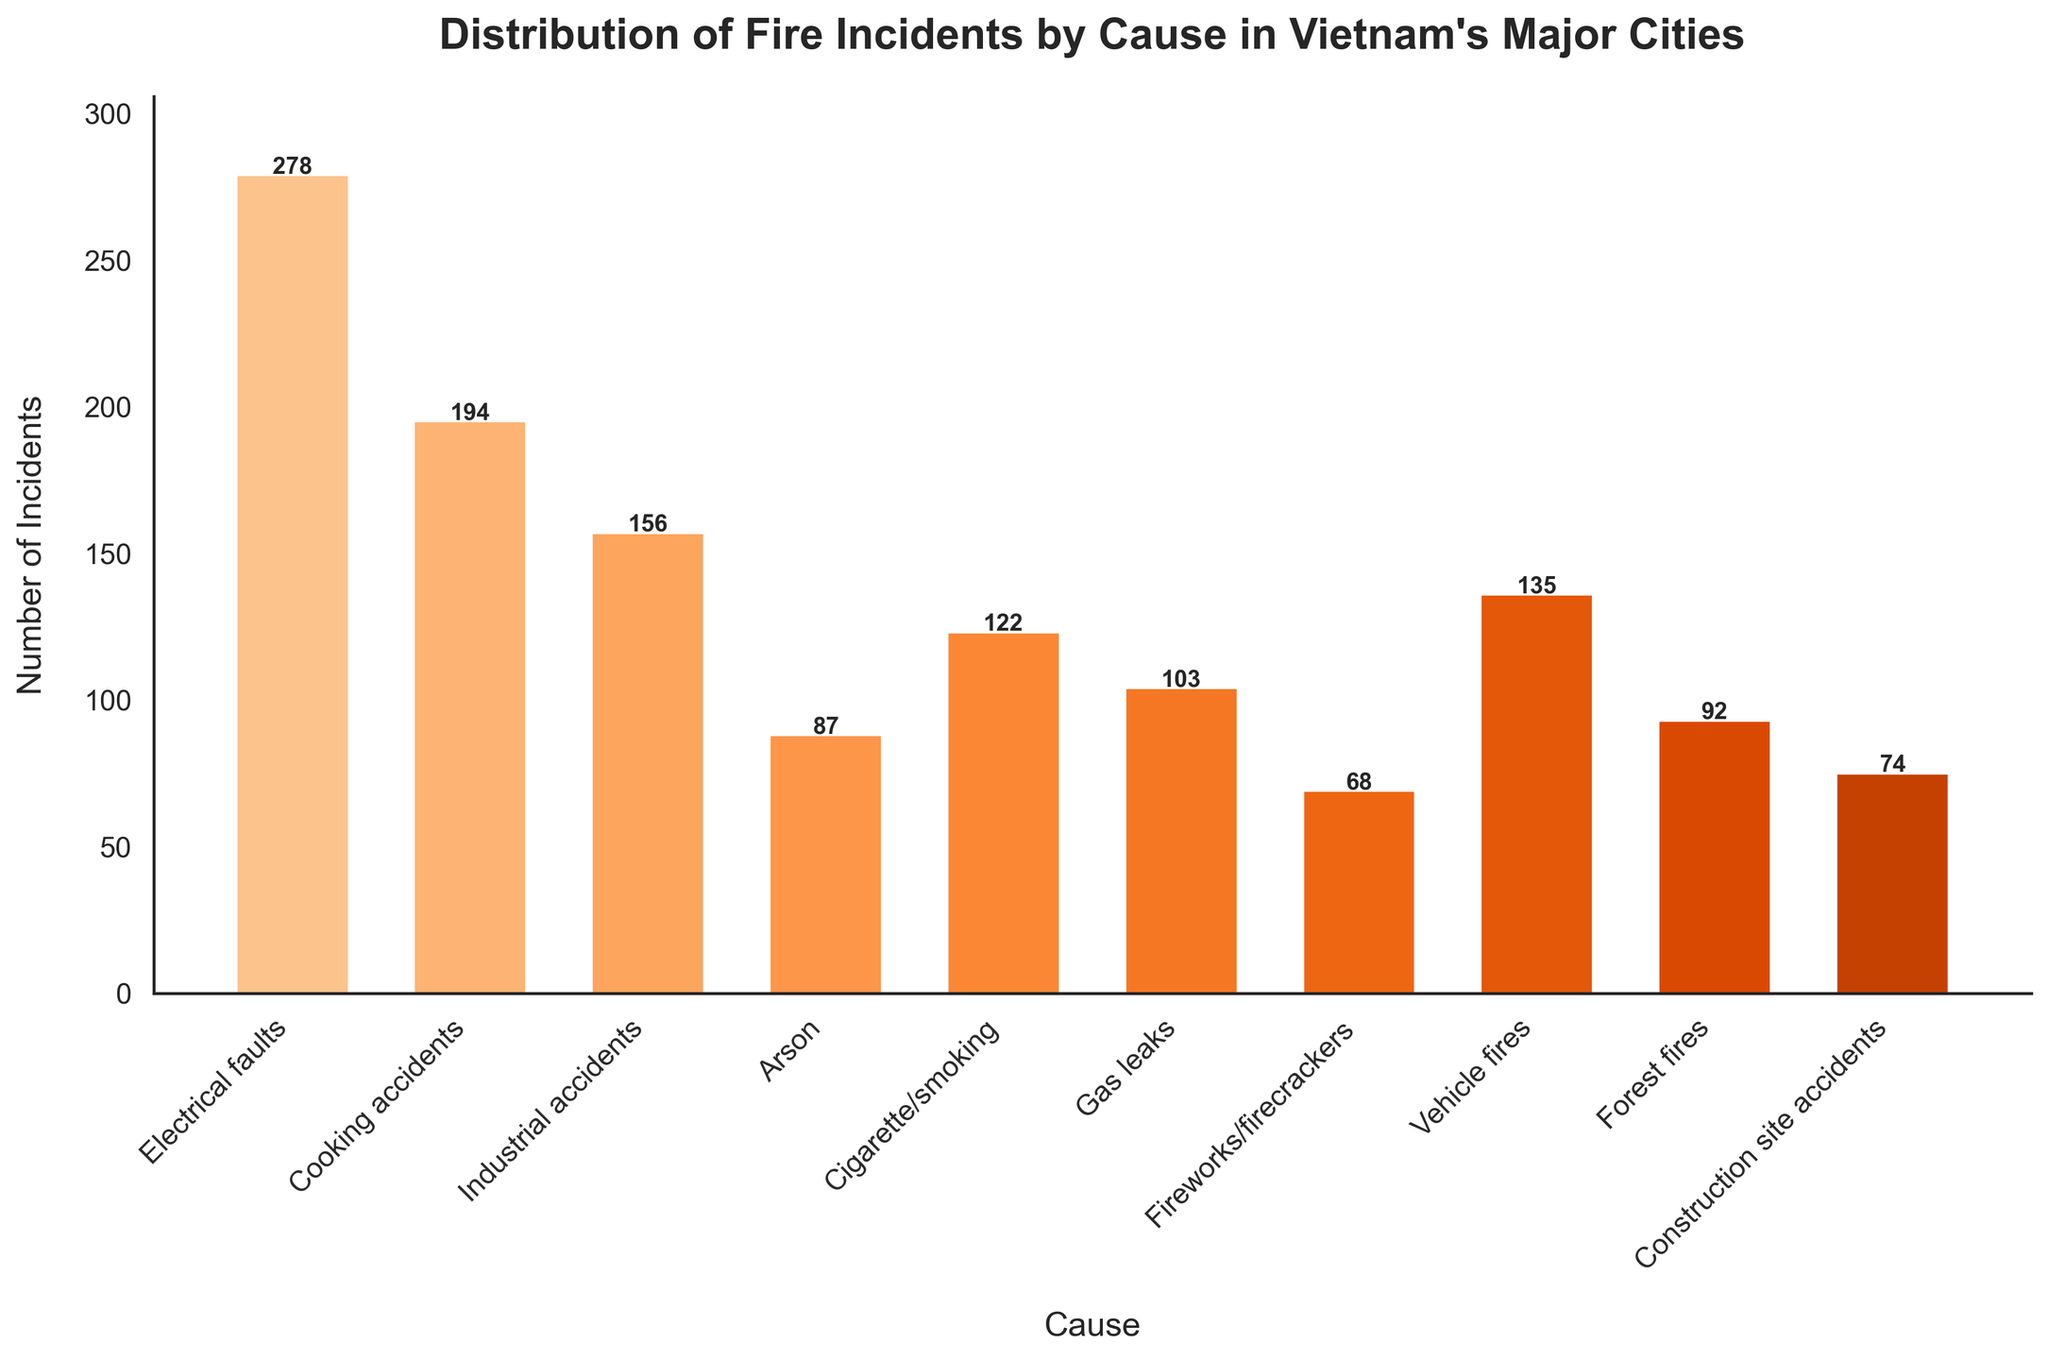Which cause has the highest number of fire incidents? To find the answer, look at the height of each bar and identify the tallest one. The bar representing "Electrical faults" is the tallest, making it the cause with the highest number of fire incidents.
Answer: Electrical faults What's the total number of incidents for Cooking accidents and Gas leaks combined? Add the incidents from the "Cooking accidents" bar (194) with the incidents from the "Gas leaks" bar (103). \(194 + 103 = 297\).
Answer: 297 Which cause has fewer incidents: Arson or Forest fires? Observe the heights of the bars for "Arson" and "Forest fires" and compare them. The bar for "Arson" is taller (87 incidents) compared to "Forest fires" (92 incidents).
Answer: Arson How many more incidents are caused by Electrical faults compared to Cigarette/smoking? Subtract the number of incidents of "Cigarette/smoking" (122) from the incidents of "Electrical faults" (278). \(278 - 122 = 156\).
Answer: 156 What is the average number of incidents for Industrial accidents, Vehicle fires, and Construction site accidents? Calculate the sum of incidents for "Industrial accidents" (156), "Vehicle fires" (135), and "Construction site accidents" (74). Then divide by 3. \((156 + 135 + 74)/3 = 365/3 = 121.67\).
Answer: 121.67 Which cause has the smallest number of incidents? Identify the shortest bar in the chart which corresponds to the cause with the smallest number of incidents. The bar for "Fireworks/firecrackers" is the shortest, indicating it has the least number of fire incidents.
Answer: Fireworks/firecrackers What color predominantly represents a higher number of incidents? Observe the color intensity in the chart, noting that bars with more incidents are visually darker. The darker bars, representing higher numbers of incidents, use a darker shade of orange.
Answer: Darker orange How do the incidents from Vehicle fires compare to those from Cooking accidents? Compare the heights of the bars for "Vehicle fires" (135 incidents) and "Cooking accidents" (194 incidents). "Cooking accidents" have more incidents than "Vehicle fires".
Answer: Cooking accidents have more What is the total number of incidents for all the causes? Add all the incidents together. \(278 + 194 + 156 + 87 + 122 + 103 + 68 + 135 + 92 + 74 = 1309\).
Answer: 1309 